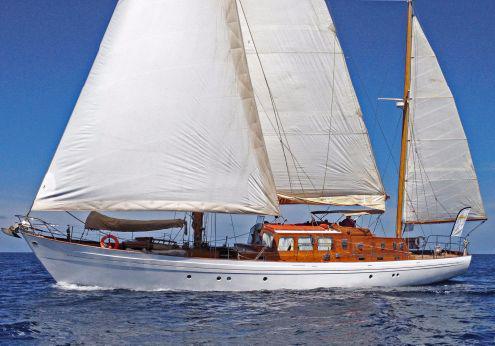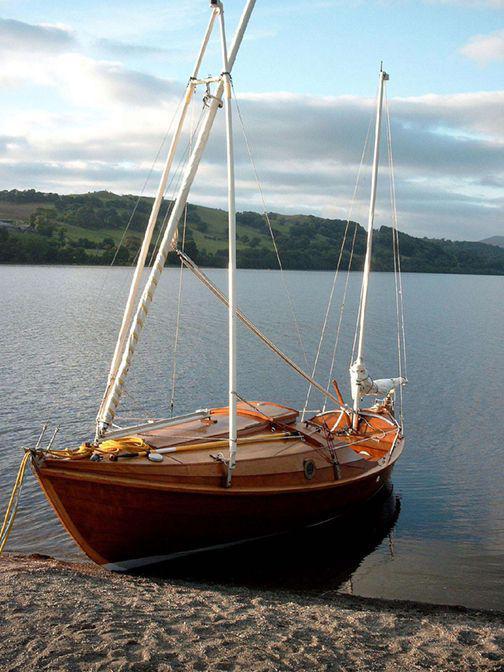The first image is the image on the left, the second image is the image on the right. For the images shown, is this caption "Trees can be seen in the background of the image on the left." true? Answer yes or no. No. 